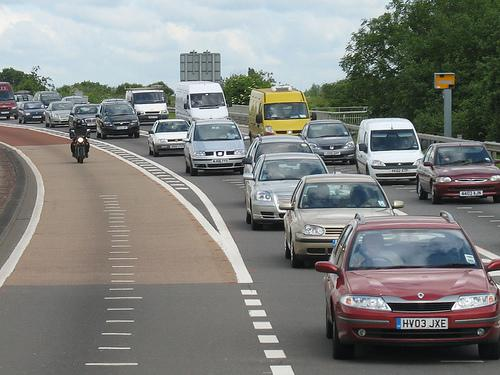Question: who is in the car?
Choices:
A. Passenger.
B. A driver.
C. Students.
D. Children.
Answer with the letter. Answer: B Question: what are these people doing?
Choices:
A. Laughing.
B. Singing.
C. Driving.
D. Going to church.
Answer with the letter. Answer: C Question: where was this picture taken?
Choices:
A. On a road.
B. On the mountain.
C. In the living room.
D. In the park.
Answer with the letter. Answer: A Question: how many vehicles are in the picture?
Choices:
A. 13.
B. 15.
C. 20.
D. 21.
Answer with the letter. Answer: D Question: why is the motorcycle in its own lane?
Choices:
A. No traffic.
B. The law.
C. Traffic.
D. Merging.
Answer with the letter. Answer: D Question: what time of day might this have been taken?
Choices:
A. Morning.
B. Rush hour.
C. Afternoon.
D. Dawn.
Answer with the letter. Answer: B 